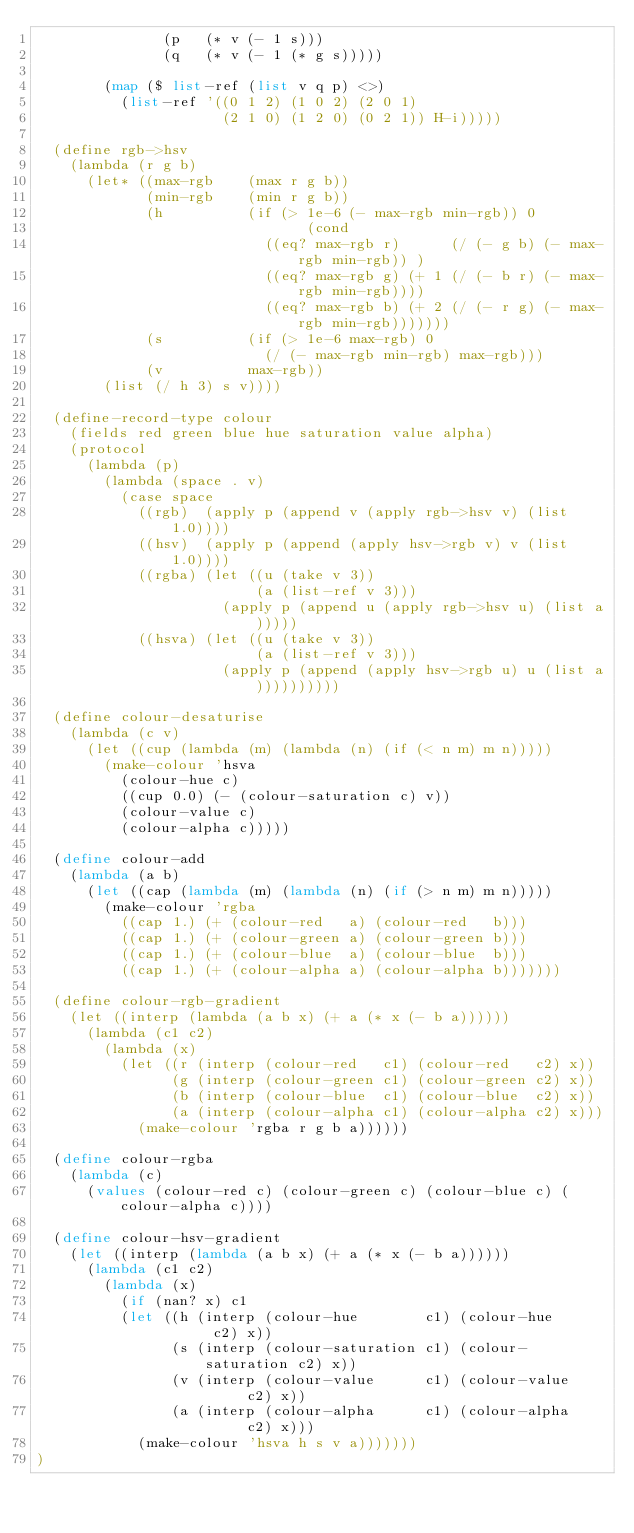Convert code to text. <code><loc_0><loc_0><loc_500><loc_500><_Scheme_>               (p   (* v (- 1 s)))
               (q   (* v (- 1 (* g s)))))

        (map ($ list-ref (list v q p) <>)
          (list-ref '((0 1 2) (1 0 2) (2 0 1)
                      (2 1 0) (1 2 0) (0 2 1)) H-i)))))

  (define rgb->hsv
    (lambda (r g b)
      (let* ((max-rgb    (max r g b))
             (min-rgb    (min r g b))
             (h          (if (> 1e-6 (- max-rgb min-rgb)) 0
                                (cond
                           ((eq? max-rgb r)      (/ (- g b) (- max-rgb min-rgb)) )
                           ((eq? max-rgb g) (+ 1 (/ (- b r) (- max-rgb min-rgb))))
                           ((eq? max-rgb b) (+ 2 (/ (- r g) (- max-rgb min-rgb)))))))
             (s          (if (> 1e-6 max-rgb) 0
                           (/ (- max-rgb min-rgb) max-rgb)))
             (v          max-rgb))
        (list (/ h 3) s v))))

  (define-record-type colour
    (fields red green blue hue saturation value alpha)
    (protocol
      (lambda (p)
        (lambda (space . v)
          (case space
            ((rgb)  (apply p (append v (apply rgb->hsv v) (list 1.0))))
            ((hsv)  (apply p (append (apply hsv->rgb v) v (list 1.0))))
            ((rgba) (let ((u (take v 3))
                          (a (list-ref v 3)))
                      (apply p (append u (apply rgb->hsv u) (list a)))))
            ((hsva) (let ((u (take v 3))
                          (a (list-ref v 3)))
                      (apply p (append (apply hsv->rgb u) u (list a))))))))))

  (define colour-desaturise
    (lambda (c v)
      (let ((cup (lambda (m) (lambda (n) (if (< n m) m n)))))
        (make-colour 'hsva
          (colour-hue c)
          ((cup 0.0) (- (colour-saturation c) v))
          (colour-value c)
          (colour-alpha c)))))

  (define colour-add
    (lambda (a b)
      (let ((cap (lambda (m) (lambda (n) (if (> n m) m n)))))
        (make-colour 'rgba
          ((cap 1.) (+ (colour-red   a) (colour-red   b)))
          ((cap 1.) (+ (colour-green a) (colour-green b)))
          ((cap 1.) (+ (colour-blue  a) (colour-blue  b)))
          ((cap 1.) (+ (colour-alpha a) (colour-alpha b)))))))

  (define colour-rgb-gradient
    (let ((interp (lambda (a b x) (+ a (* x (- b a))))))
      (lambda (c1 c2)
        (lambda (x)
          (let ((r (interp (colour-red   c1) (colour-red   c2) x))
                (g (interp (colour-green c1) (colour-green c2) x))
                (b (interp (colour-blue  c1) (colour-blue  c2) x))
                (a (interp (colour-alpha c1) (colour-alpha c2) x)))
            (make-colour 'rgba r g b a))))))

  (define colour-rgba
    (lambda (c)
      (values (colour-red c) (colour-green c) (colour-blue c) (colour-alpha c))))

  (define colour-hsv-gradient
    (let ((interp (lambda (a b x) (+ a (* x (- b a))))))
      (lambda (c1 c2)
        (lambda (x)
          (if (nan? x) c1
          (let ((h (interp (colour-hue        c1) (colour-hue        c2) x))
                (s (interp (colour-saturation c1) (colour-saturation c2) x))
                (v (interp (colour-value      c1) (colour-value      c2) x))
                (a (interp (colour-alpha      c1) (colour-alpha      c2) x)))
            (make-colour 'hsva h s v a)))))))
)

</code> 